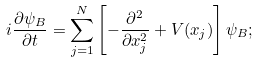<formula> <loc_0><loc_0><loc_500><loc_500>i \frac { \partial \psi _ { B } } { \partial t } = \sum _ { j = 1 } ^ { N } \left [ - \frac { \partial ^ { 2 } } { \partial x _ { j } ^ { 2 } } + V ( x _ { j } ) \right ] \psi _ { B } ;</formula> 